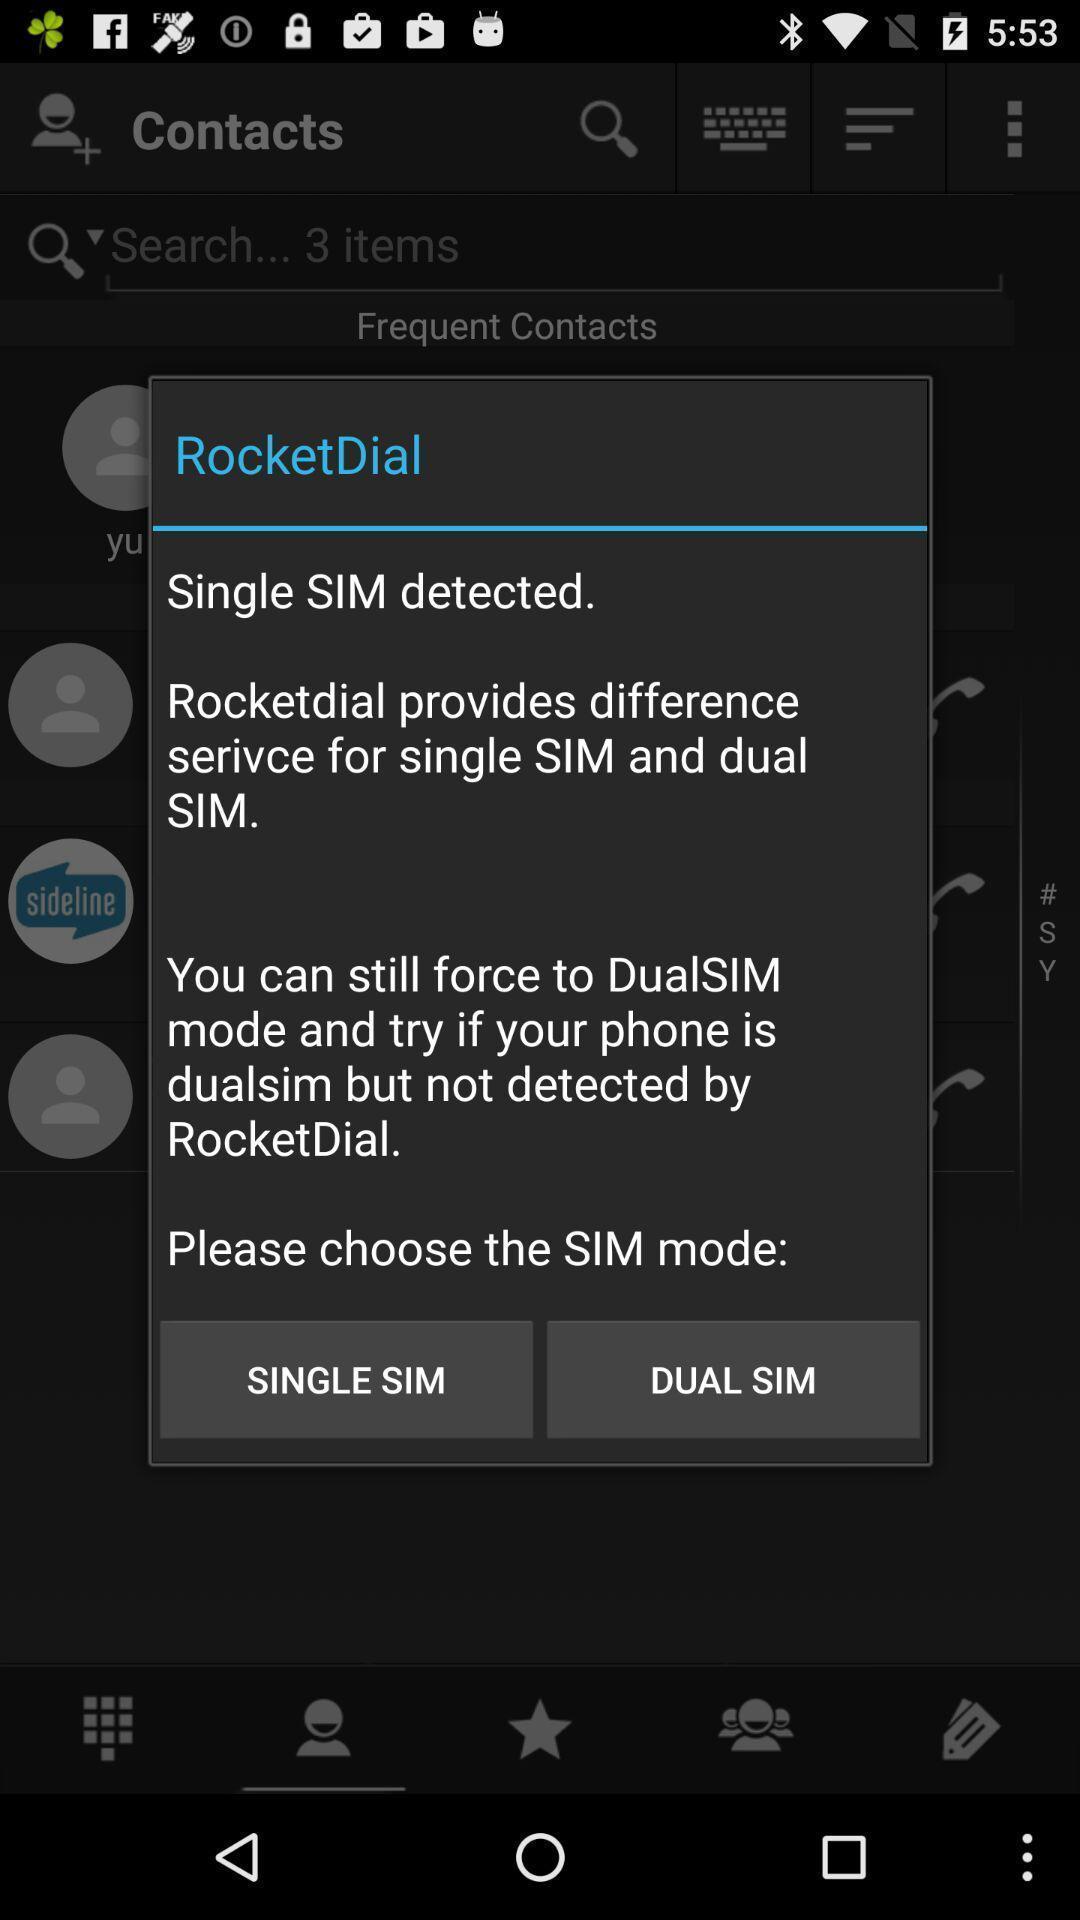Please provide a description for this image. Pop-up displaying to choose the sim mode. 